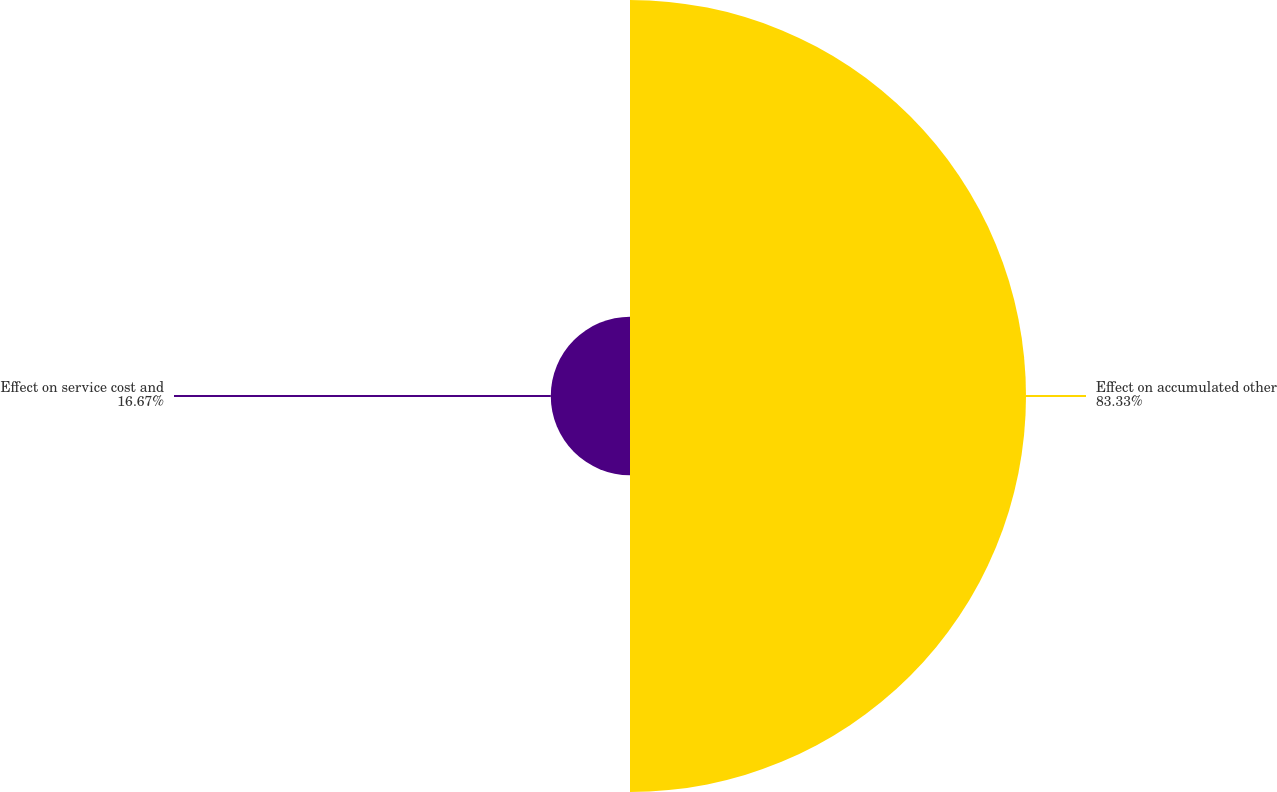Convert chart. <chart><loc_0><loc_0><loc_500><loc_500><pie_chart><fcel>Effect on accumulated other<fcel>Effect on service cost and<nl><fcel>83.33%<fcel>16.67%<nl></chart> 